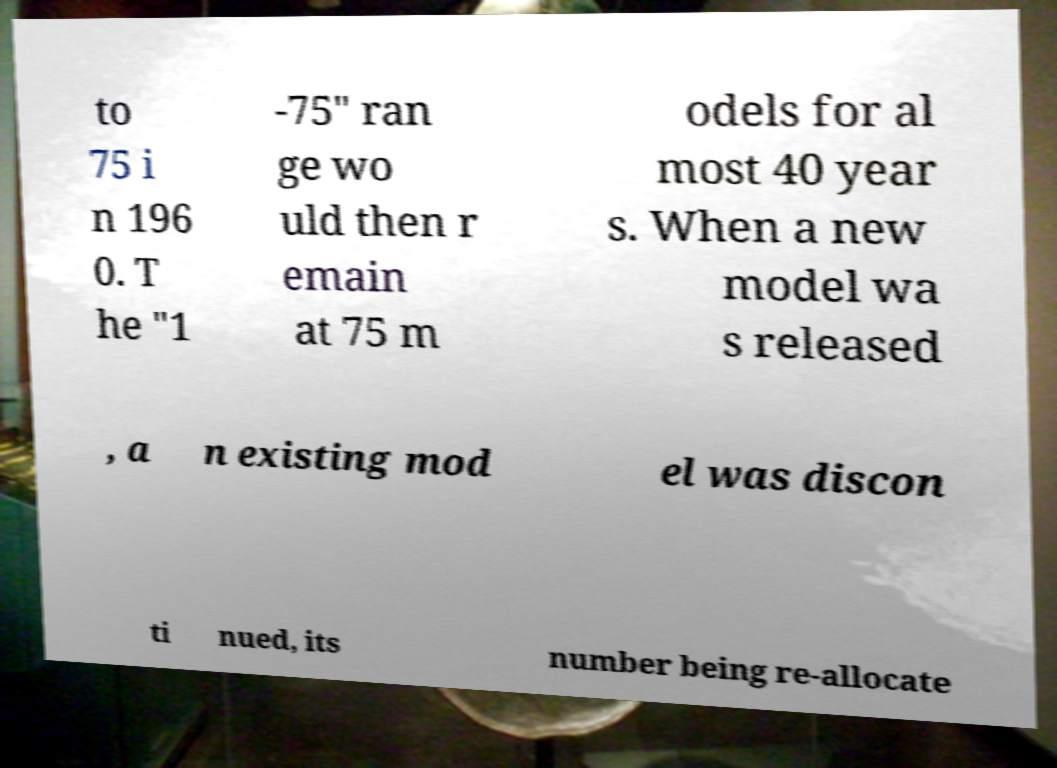Please read and relay the text visible in this image. What does it say? to 75 i n 196 0. T he "1 -75" ran ge wo uld then r emain at 75 m odels for al most 40 year s. When a new model wa s released , a n existing mod el was discon ti nued, its number being re-allocate 